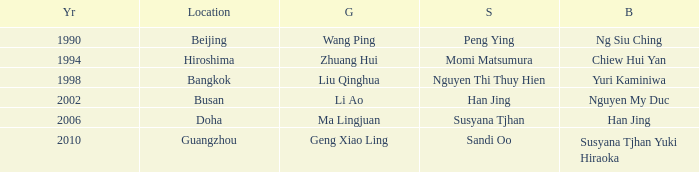What Gold has the Year of 2006? Ma Lingjuan. 